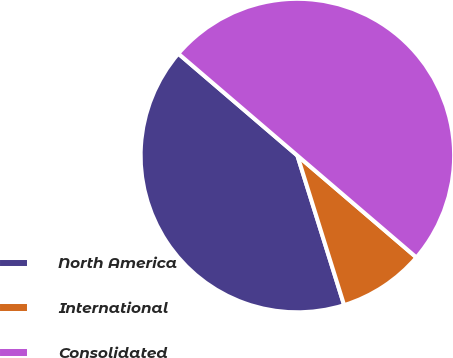<chart> <loc_0><loc_0><loc_500><loc_500><pie_chart><fcel>North America<fcel>International<fcel>Consolidated<nl><fcel>41.09%<fcel>8.91%<fcel>50.0%<nl></chart> 